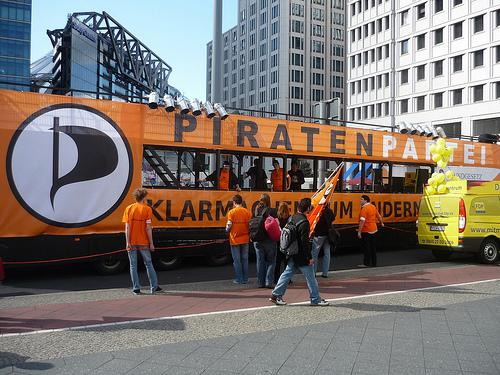Question: where was this picture taken?
Choices:
A. A street.
B. A store front.
C. A city.
D. A park.
Answer with the letter. Answer: C Question: what color flag is the man holding?
Choices:
A. Teal.
B. Purple.
C. Neon.
D. Orange.
Answer with the letter. Answer: D 